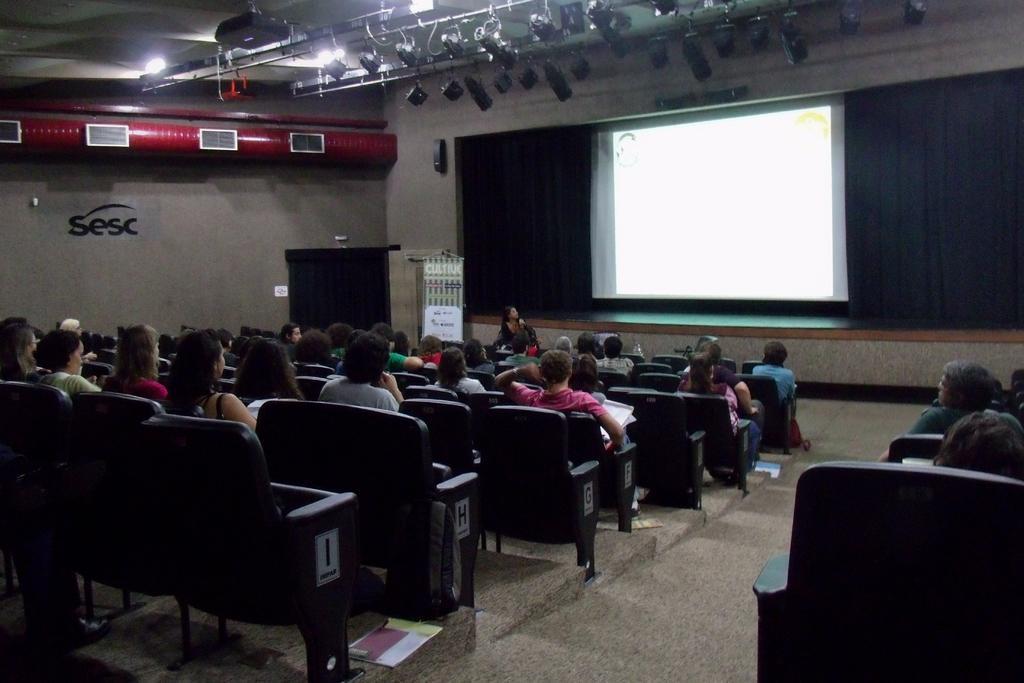Can you describe this image briefly? In this image there are group of people sitting in chair , and the back ground there are lights , screen , podium. 